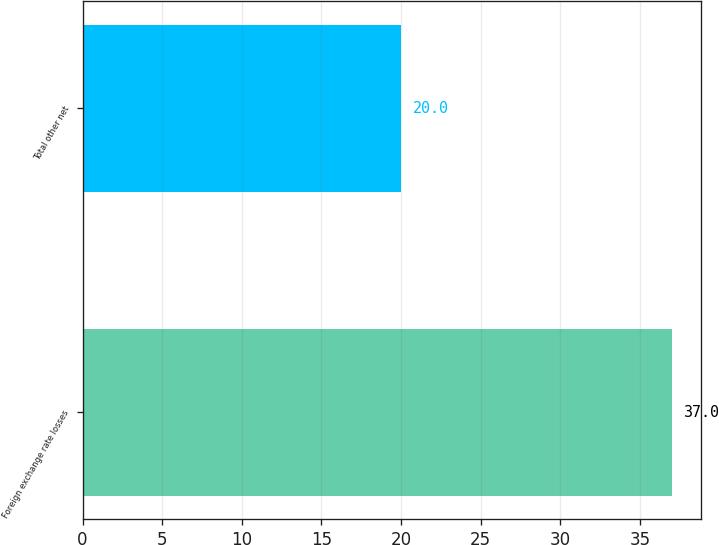Convert chart to OTSL. <chart><loc_0><loc_0><loc_500><loc_500><bar_chart><fcel>Foreign exchange rate losses<fcel>Total other net<nl><fcel>37<fcel>20<nl></chart> 